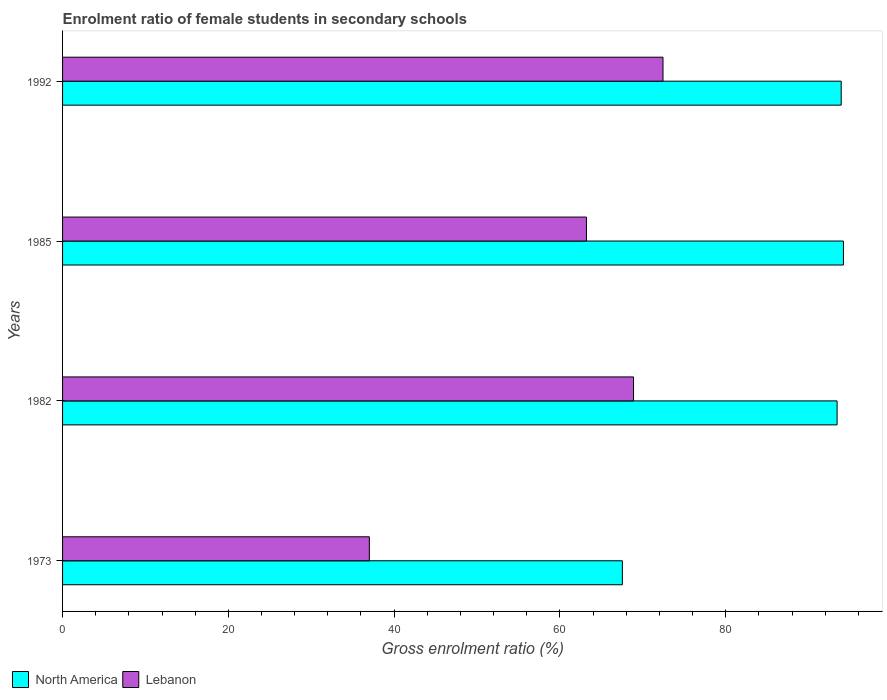How many groups of bars are there?
Give a very brief answer. 4. Are the number of bars on each tick of the Y-axis equal?
Make the answer very short. Yes. How many bars are there on the 4th tick from the top?
Provide a succinct answer. 2. How many bars are there on the 2nd tick from the bottom?
Ensure brevity in your answer.  2. What is the enrolment ratio of female students in secondary schools in North America in 1982?
Keep it short and to the point. 93.44. Across all years, what is the maximum enrolment ratio of female students in secondary schools in North America?
Give a very brief answer. 94.2. Across all years, what is the minimum enrolment ratio of female students in secondary schools in Lebanon?
Give a very brief answer. 37.01. In which year was the enrolment ratio of female students in secondary schools in North America maximum?
Offer a very short reply. 1985. What is the total enrolment ratio of female students in secondary schools in North America in the graph?
Give a very brief answer. 349.11. What is the difference between the enrolment ratio of female students in secondary schools in Lebanon in 1973 and that in 1985?
Give a very brief answer. -26.19. What is the difference between the enrolment ratio of female students in secondary schools in North America in 1985 and the enrolment ratio of female students in secondary schools in Lebanon in 1973?
Your answer should be compact. 57.19. What is the average enrolment ratio of female students in secondary schools in North America per year?
Ensure brevity in your answer.  87.28. In the year 1992, what is the difference between the enrolment ratio of female students in secondary schools in North America and enrolment ratio of female students in secondary schools in Lebanon?
Your response must be concise. 21.5. In how many years, is the enrolment ratio of female students in secondary schools in Lebanon greater than 60 %?
Provide a short and direct response. 3. What is the ratio of the enrolment ratio of female students in secondary schools in Lebanon in 1973 to that in 1985?
Your answer should be very brief. 0.59. Is the enrolment ratio of female students in secondary schools in North America in 1985 less than that in 1992?
Offer a terse response. No. Is the difference between the enrolment ratio of female students in secondary schools in North America in 1982 and 1992 greater than the difference between the enrolment ratio of female students in secondary schools in Lebanon in 1982 and 1992?
Make the answer very short. Yes. What is the difference between the highest and the second highest enrolment ratio of female students in secondary schools in North America?
Provide a short and direct response. 0.27. What is the difference between the highest and the lowest enrolment ratio of female students in secondary schools in North America?
Provide a short and direct response. 26.67. Is the sum of the enrolment ratio of female students in secondary schools in North America in 1985 and 1992 greater than the maximum enrolment ratio of female students in secondary schools in Lebanon across all years?
Offer a terse response. Yes. What does the 1st bar from the top in 1992 represents?
Offer a terse response. Lebanon. What does the 1st bar from the bottom in 1973 represents?
Provide a short and direct response. North America. How many bars are there?
Your answer should be compact. 8. What is the difference between two consecutive major ticks on the X-axis?
Offer a very short reply. 20. Does the graph contain grids?
Offer a terse response. No. How many legend labels are there?
Offer a very short reply. 2. What is the title of the graph?
Your answer should be compact. Enrolment ratio of female students in secondary schools. What is the label or title of the X-axis?
Provide a short and direct response. Gross enrolment ratio (%). What is the Gross enrolment ratio (%) in North America in 1973?
Offer a very short reply. 67.53. What is the Gross enrolment ratio (%) in Lebanon in 1973?
Give a very brief answer. 37.01. What is the Gross enrolment ratio (%) in North America in 1982?
Keep it short and to the point. 93.44. What is the Gross enrolment ratio (%) of Lebanon in 1982?
Provide a succinct answer. 68.88. What is the Gross enrolment ratio (%) in North America in 1985?
Offer a terse response. 94.2. What is the Gross enrolment ratio (%) in Lebanon in 1985?
Offer a terse response. 63.2. What is the Gross enrolment ratio (%) of North America in 1992?
Provide a succinct answer. 93.93. What is the Gross enrolment ratio (%) of Lebanon in 1992?
Ensure brevity in your answer.  72.44. Across all years, what is the maximum Gross enrolment ratio (%) in North America?
Give a very brief answer. 94.2. Across all years, what is the maximum Gross enrolment ratio (%) in Lebanon?
Make the answer very short. 72.44. Across all years, what is the minimum Gross enrolment ratio (%) in North America?
Offer a terse response. 67.53. Across all years, what is the minimum Gross enrolment ratio (%) of Lebanon?
Keep it short and to the point. 37.01. What is the total Gross enrolment ratio (%) in North America in the graph?
Offer a very short reply. 349.11. What is the total Gross enrolment ratio (%) in Lebanon in the graph?
Your response must be concise. 241.53. What is the difference between the Gross enrolment ratio (%) in North America in 1973 and that in 1982?
Your response must be concise. -25.9. What is the difference between the Gross enrolment ratio (%) in Lebanon in 1973 and that in 1982?
Provide a succinct answer. -31.87. What is the difference between the Gross enrolment ratio (%) in North America in 1973 and that in 1985?
Ensure brevity in your answer.  -26.67. What is the difference between the Gross enrolment ratio (%) in Lebanon in 1973 and that in 1985?
Keep it short and to the point. -26.19. What is the difference between the Gross enrolment ratio (%) of North America in 1973 and that in 1992?
Offer a terse response. -26.4. What is the difference between the Gross enrolment ratio (%) of Lebanon in 1973 and that in 1992?
Ensure brevity in your answer.  -35.43. What is the difference between the Gross enrolment ratio (%) in North America in 1982 and that in 1985?
Make the answer very short. -0.77. What is the difference between the Gross enrolment ratio (%) of Lebanon in 1982 and that in 1985?
Your answer should be compact. 5.68. What is the difference between the Gross enrolment ratio (%) in North America in 1982 and that in 1992?
Your answer should be very brief. -0.5. What is the difference between the Gross enrolment ratio (%) in Lebanon in 1982 and that in 1992?
Your answer should be very brief. -3.56. What is the difference between the Gross enrolment ratio (%) of North America in 1985 and that in 1992?
Ensure brevity in your answer.  0.27. What is the difference between the Gross enrolment ratio (%) of Lebanon in 1985 and that in 1992?
Provide a short and direct response. -9.23. What is the difference between the Gross enrolment ratio (%) of North America in 1973 and the Gross enrolment ratio (%) of Lebanon in 1982?
Your answer should be compact. -1.35. What is the difference between the Gross enrolment ratio (%) of North America in 1973 and the Gross enrolment ratio (%) of Lebanon in 1985?
Ensure brevity in your answer.  4.33. What is the difference between the Gross enrolment ratio (%) of North America in 1973 and the Gross enrolment ratio (%) of Lebanon in 1992?
Make the answer very short. -4.9. What is the difference between the Gross enrolment ratio (%) of North America in 1982 and the Gross enrolment ratio (%) of Lebanon in 1985?
Provide a short and direct response. 30.24. What is the difference between the Gross enrolment ratio (%) of North America in 1982 and the Gross enrolment ratio (%) of Lebanon in 1992?
Make the answer very short. 21. What is the difference between the Gross enrolment ratio (%) of North America in 1985 and the Gross enrolment ratio (%) of Lebanon in 1992?
Your response must be concise. 21.77. What is the average Gross enrolment ratio (%) of North America per year?
Give a very brief answer. 87.28. What is the average Gross enrolment ratio (%) in Lebanon per year?
Give a very brief answer. 60.38. In the year 1973, what is the difference between the Gross enrolment ratio (%) in North America and Gross enrolment ratio (%) in Lebanon?
Offer a very short reply. 30.52. In the year 1982, what is the difference between the Gross enrolment ratio (%) of North America and Gross enrolment ratio (%) of Lebanon?
Ensure brevity in your answer.  24.56. In the year 1985, what is the difference between the Gross enrolment ratio (%) of North America and Gross enrolment ratio (%) of Lebanon?
Give a very brief answer. 31. In the year 1992, what is the difference between the Gross enrolment ratio (%) in North America and Gross enrolment ratio (%) in Lebanon?
Ensure brevity in your answer.  21.5. What is the ratio of the Gross enrolment ratio (%) in North America in 1973 to that in 1982?
Offer a terse response. 0.72. What is the ratio of the Gross enrolment ratio (%) of Lebanon in 1973 to that in 1982?
Keep it short and to the point. 0.54. What is the ratio of the Gross enrolment ratio (%) of North America in 1973 to that in 1985?
Your answer should be very brief. 0.72. What is the ratio of the Gross enrolment ratio (%) in Lebanon in 1973 to that in 1985?
Your answer should be compact. 0.59. What is the ratio of the Gross enrolment ratio (%) of North America in 1973 to that in 1992?
Keep it short and to the point. 0.72. What is the ratio of the Gross enrolment ratio (%) of Lebanon in 1973 to that in 1992?
Offer a terse response. 0.51. What is the ratio of the Gross enrolment ratio (%) in Lebanon in 1982 to that in 1985?
Your answer should be compact. 1.09. What is the ratio of the Gross enrolment ratio (%) in Lebanon in 1982 to that in 1992?
Ensure brevity in your answer.  0.95. What is the ratio of the Gross enrolment ratio (%) of Lebanon in 1985 to that in 1992?
Provide a short and direct response. 0.87. What is the difference between the highest and the second highest Gross enrolment ratio (%) of North America?
Give a very brief answer. 0.27. What is the difference between the highest and the second highest Gross enrolment ratio (%) of Lebanon?
Make the answer very short. 3.56. What is the difference between the highest and the lowest Gross enrolment ratio (%) of North America?
Your response must be concise. 26.67. What is the difference between the highest and the lowest Gross enrolment ratio (%) of Lebanon?
Give a very brief answer. 35.43. 